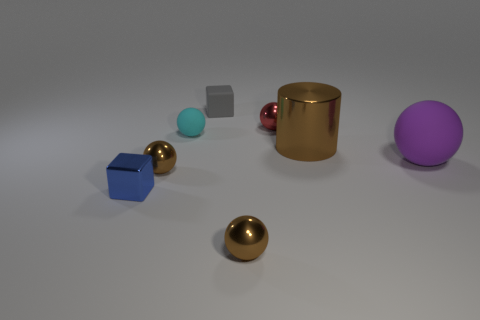Subtract all cyan spheres. How many spheres are left? 4 Subtract all cyan balls. How many balls are left? 4 Subtract all gray spheres. Subtract all brown cylinders. How many spheres are left? 5 Add 2 small brown balls. How many objects exist? 10 Subtract all spheres. How many objects are left? 3 Add 6 rubber objects. How many rubber objects are left? 9 Add 6 tiny blue objects. How many tiny blue objects exist? 7 Subtract 0 gray cylinders. How many objects are left? 8 Subtract all matte cubes. Subtract all brown metallic spheres. How many objects are left? 5 